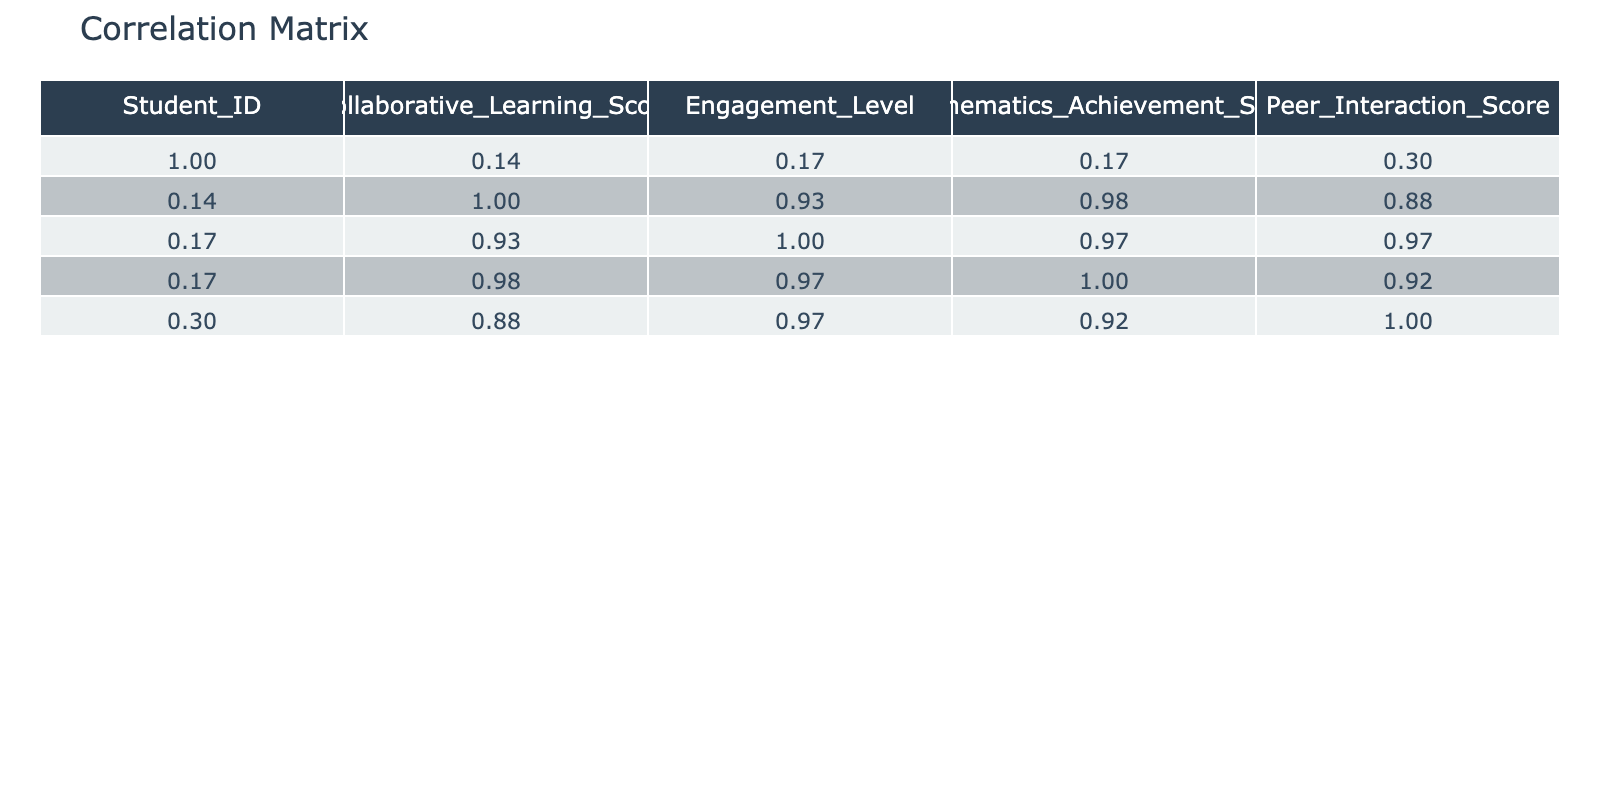What is the correlation coefficient between Collaborative Learning Score and Mathematics Achievement Score? The correlation matrix shows that the value in the row for Collaborative Learning Score and the column for Mathematics Achievement Score is 0.93.
Answer: 0.93 What is the Engagement Level for Student ID 5? Looking at the row for Student ID 5, the Engagement Level is 5.
Answer: 5 Is there a positive correlation between Peer Interaction Score and Engagement Level? The correlation matrix indicates that the correlation coefficient between Peer Interaction Score and Engagement Level is 0.72, which is positive.
Answer: Yes What is the average Collaborative Learning Score for all students? To calculate the average, sum all Collaborative Learning Scores (4.5 + 3.8 + 5.0 + 4.2 + 3.5 + 4.7 + 3.9 + 4.8 + 5.0 + 4.1 = 48.5), then divide by the number of students (10): 48.5 / 10 = 4.85.
Answer: 4.85 Who has the highest Mathematics Achievement Score, and what is the score? By examining the Mathematics Achievement column, Student ID 9 is identified with the highest score of 95.
Answer: Student ID 9, 95 What is the difference between the highest and lowest Peer Interaction Scores? The highest Peer Interaction Score is 10 (Student ID 9), and the lowest is 4 (Student ID 5). Therefore, the difference is 10 - 4 = 6.
Answer: 6 Does a higher Engagement Level correlate with a higher Collaborative Learning Score based on the table? The correlation coefficient between Engagement Level and Collaborative Learning Score is 0.70, indicating a positive correlation and suggesting that as one increases, the other tends to increase as well.
Answer: Yes What are the Engagement Levels of the two students with the lowest Collaborative Learning Scores? The lowest Collaborative Learning Scores are 3.5 (Student ID 5) and 3.8 (Student ID 2), with Engagement Levels of 5 and 7 respectively.
Answer: 5 and 7 If we consider only students with Engagement Levels above 8, what is the average Mathematics Achievement Score for those students? Students with Engagement Levels above 8 are Student ID 3 (Achievement Score 92), Student ID 6 (Achievement Score 88), Student ID 8 (Achievement Score 90), and Student ID 9 (Achievement Score 95). The average is (92 + 88 + 90 + 95) / 4 = 91.25.
Answer: 91.25 